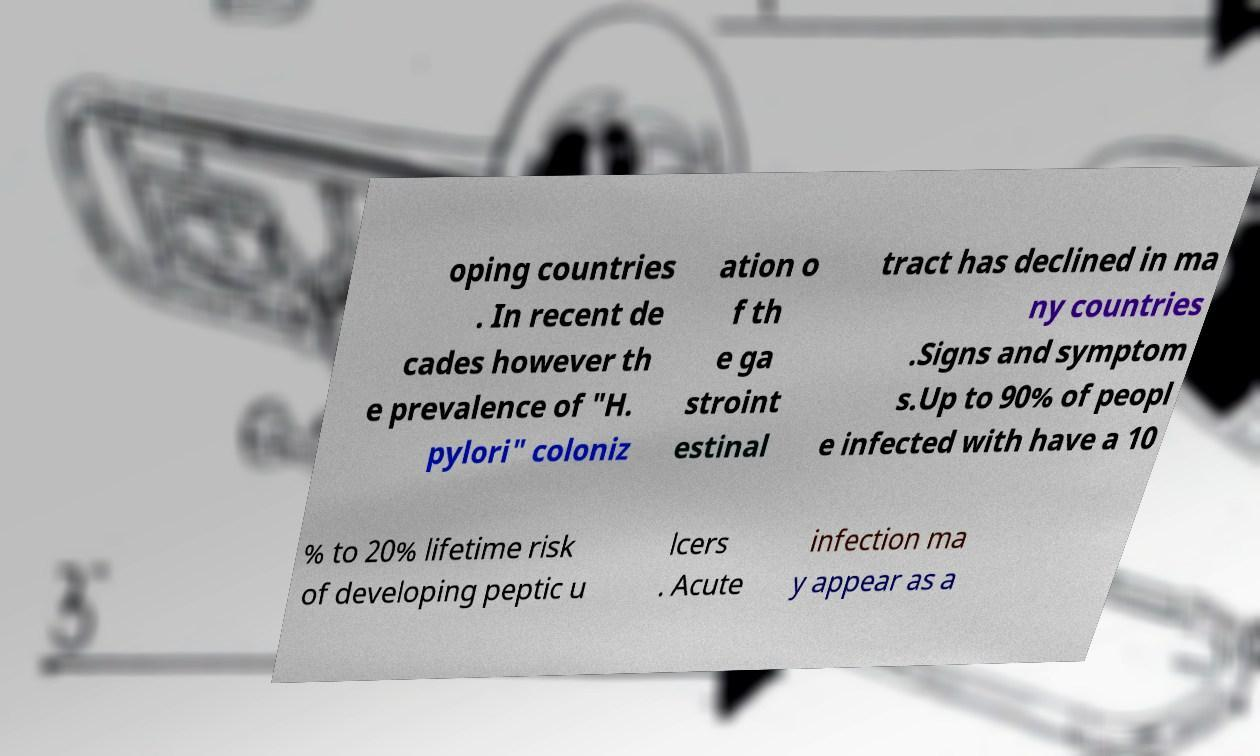There's text embedded in this image that I need extracted. Can you transcribe it verbatim? oping countries . In recent de cades however th e prevalence of "H. pylori" coloniz ation o f th e ga stroint estinal tract has declined in ma ny countries .Signs and symptom s.Up to 90% of peopl e infected with have a 10 % to 20% lifetime risk of developing peptic u lcers . Acute infection ma y appear as a 